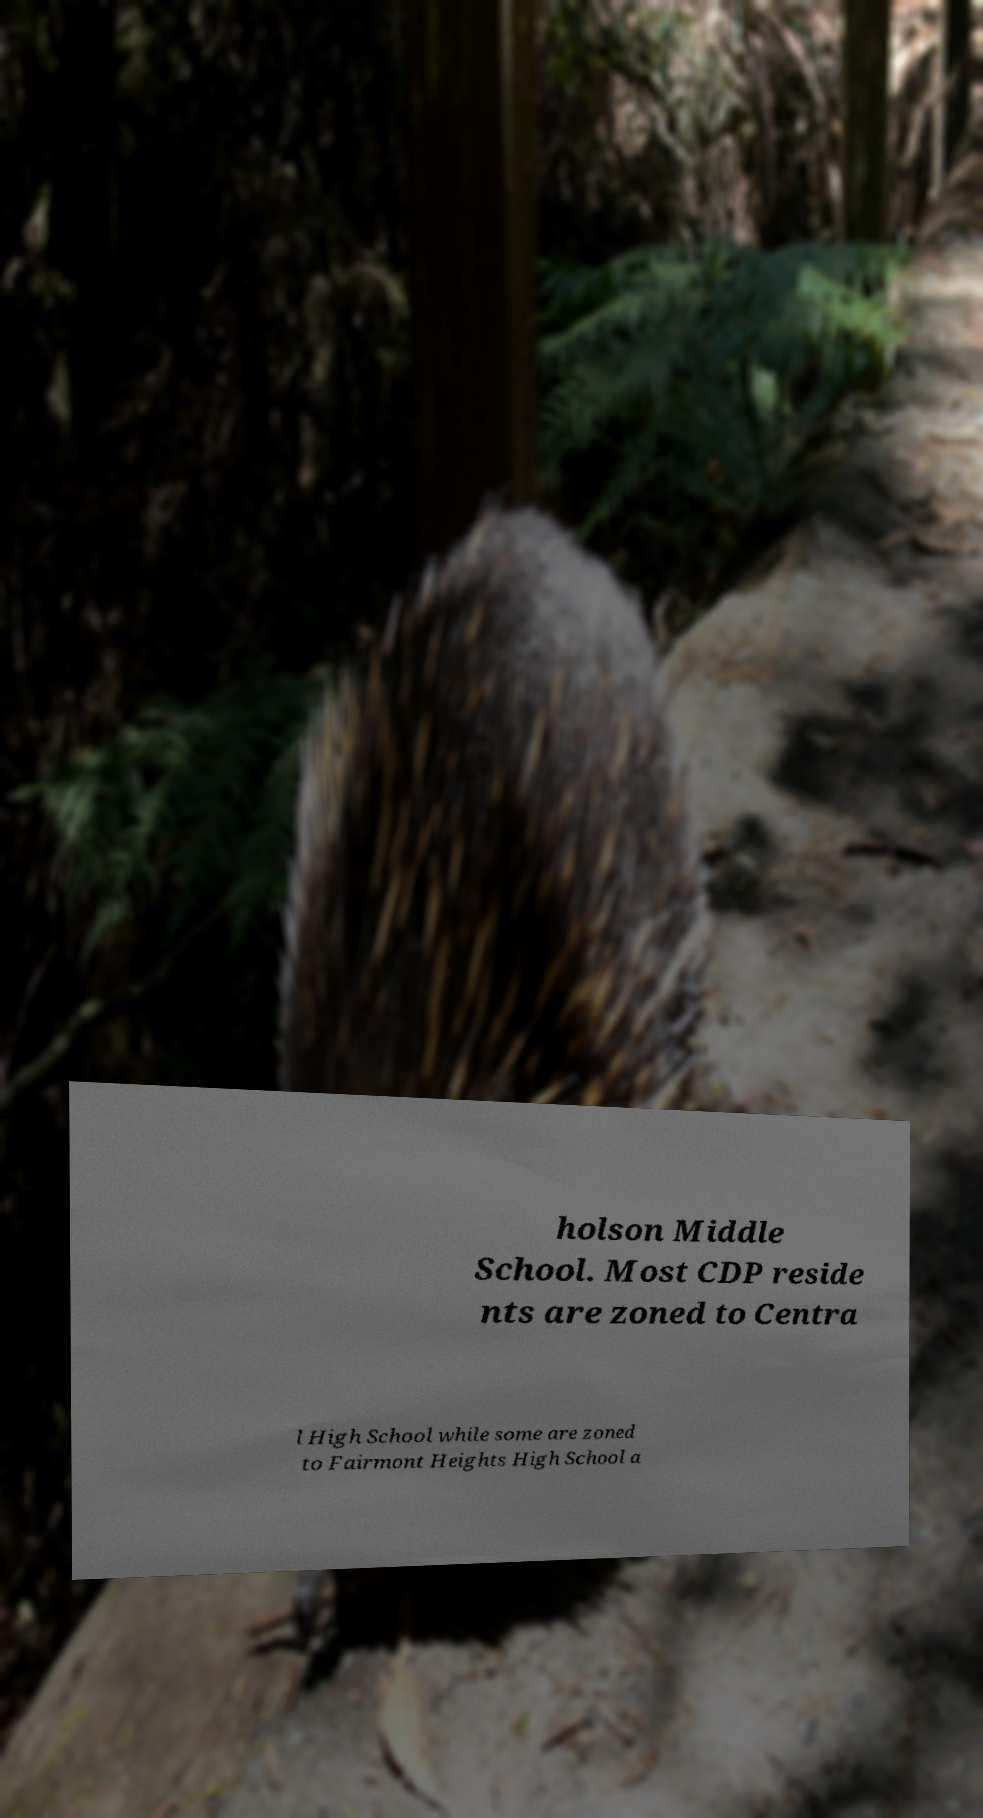Please read and relay the text visible in this image. What does it say? holson Middle School. Most CDP reside nts are zoned to Centra l High School while some are zoned to Fairmont Heights High School a 